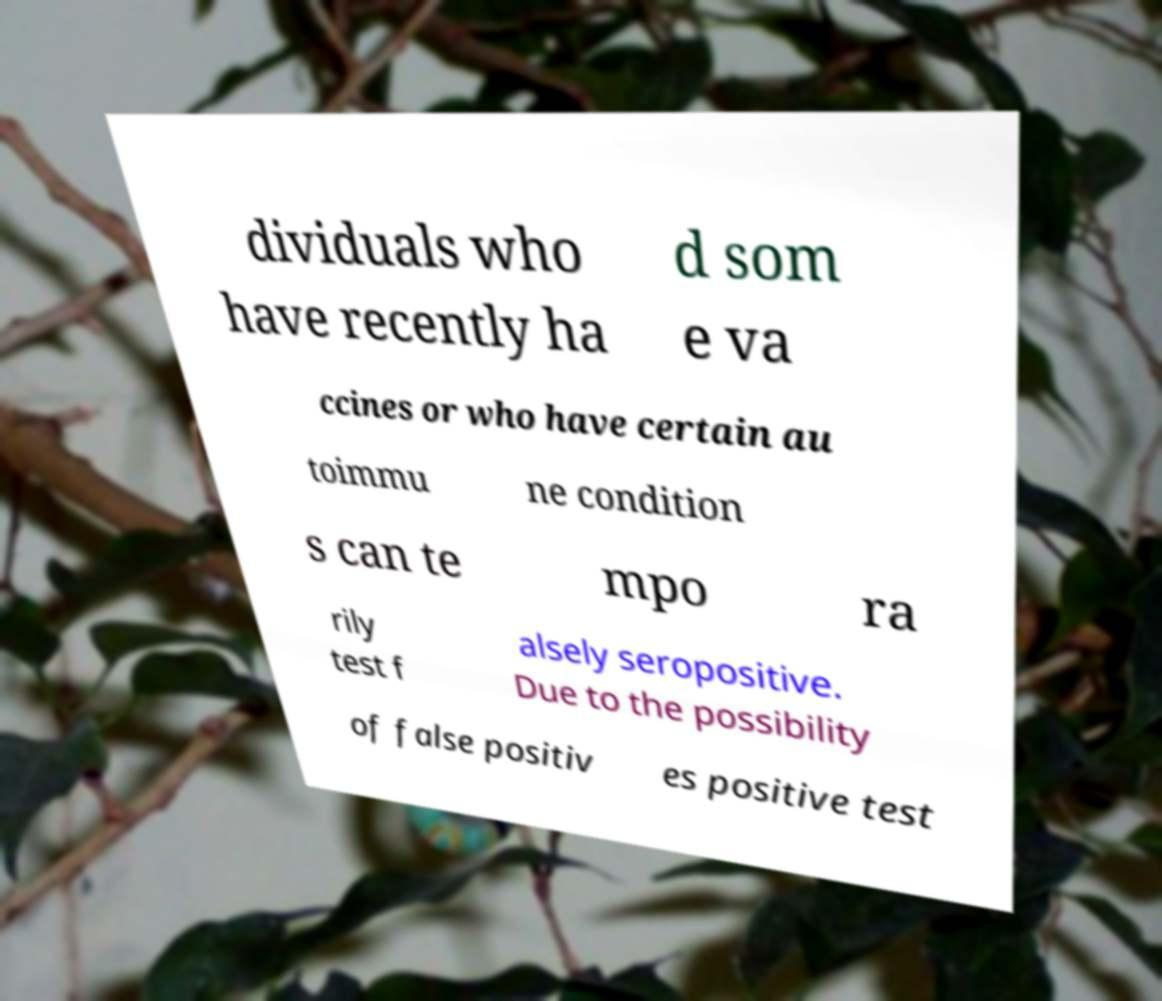For documentation purposes, I need the text within this image transcribed. Could you provide that? dividuals who have recently ha d som e va ccines or who have certain au toimmu ne condition s can te mpo ra rily test f alsely seropositive. Due to the possibility of false positiv es positive test 